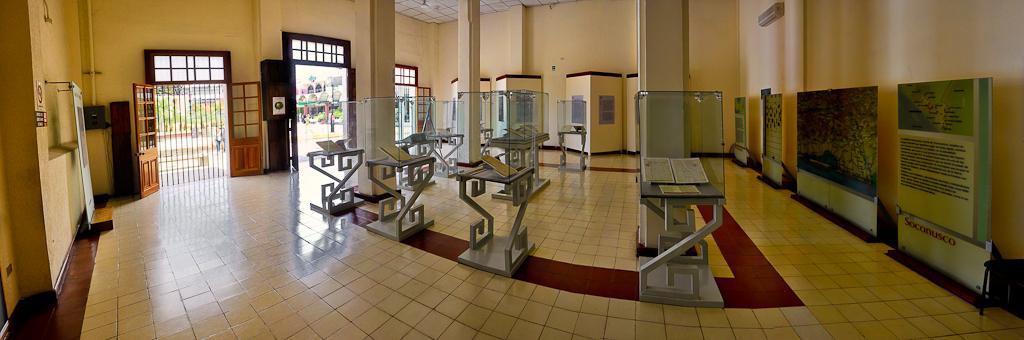In one or two sentences, can you explain what this image depicts? In the picture I can see inside of the room, in which we can see some boards along with some tables. 